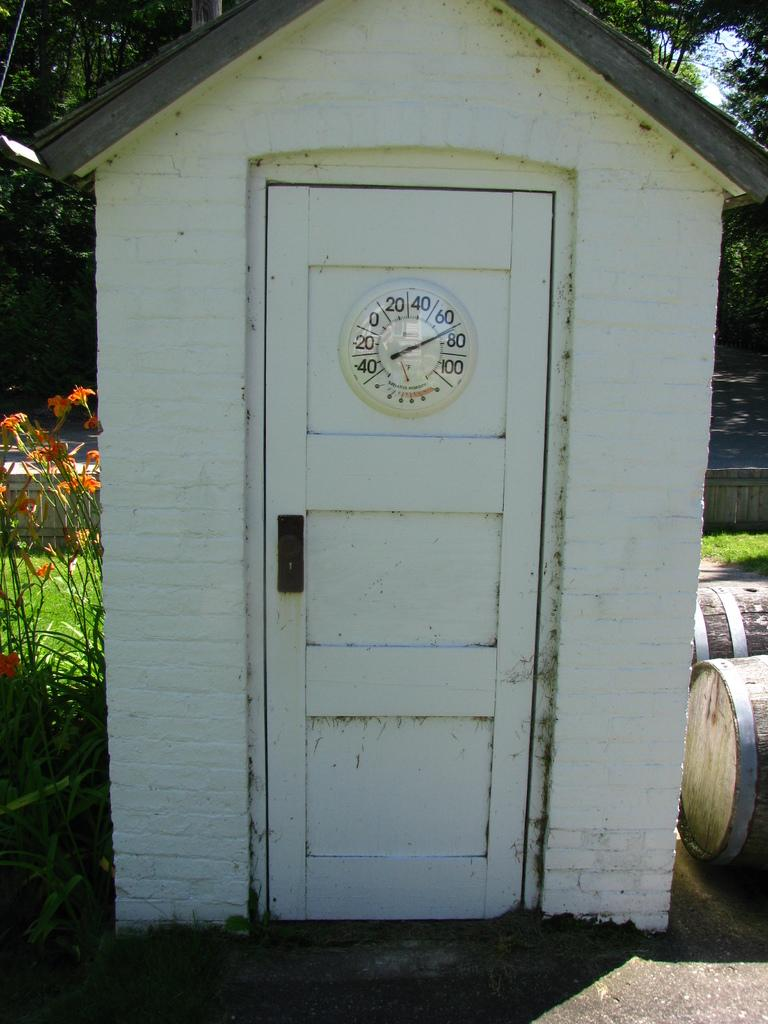Provide a one-sentence caption for the provided image. White door with a clock which has the hands in between the 60 and 80. 